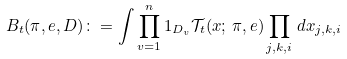<formula> <loc_0><loc_0><loc_500><loc_500>B _ { t } ( \pi , e , D ) \colon = \int \prod _ { v = 1 } ^ { n } 1 _ { D _ { v } } \mathcal { T } _ { t } ( x ; \, \pi , e ) \prod _ { j , k , i } \, d x _ { j , k , i }</formula> 